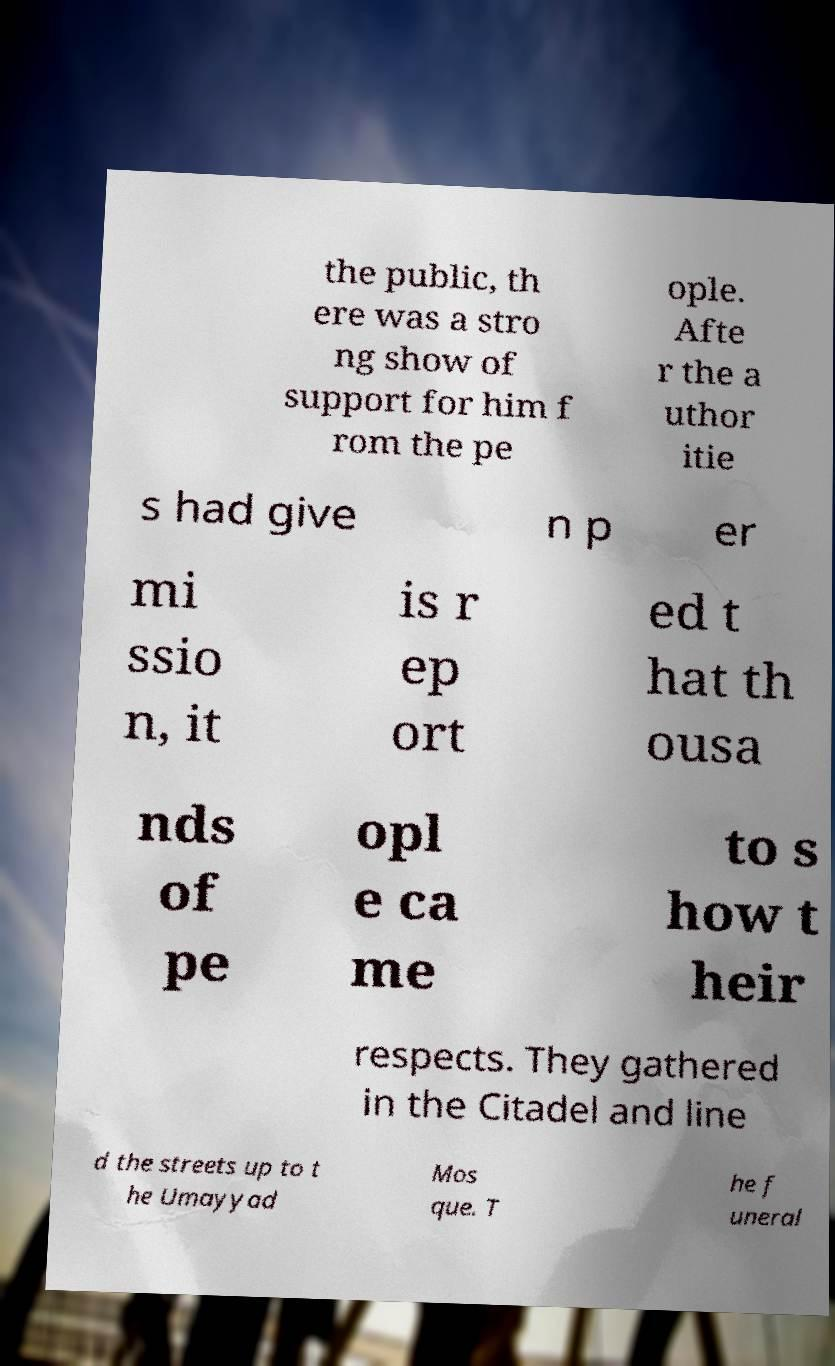What messages or text are displayed in this image? I need them in a readable, typed format. the public, th ere was a stro ng show of support for him f rom the pe ople. Afte r the a uthor itie s had give n p er mi ssio n, it is r ep ort ed t hat th ousa nds of pe opl e ca me to s how t heir respects. They gathered in the Citadel and line d the streets up to t he Umayyad Mos que. T he f uneral 